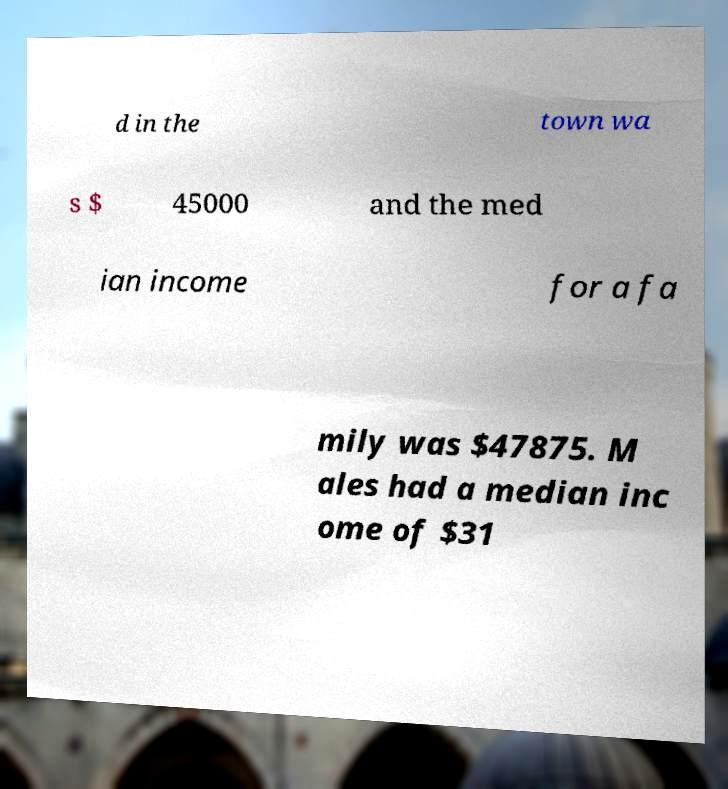Please identify and transcribe the text found in this image. d in the town wa s $ 45000 and the med ian income for a fa mily was $47875. M ales had a median inc ome of $31 